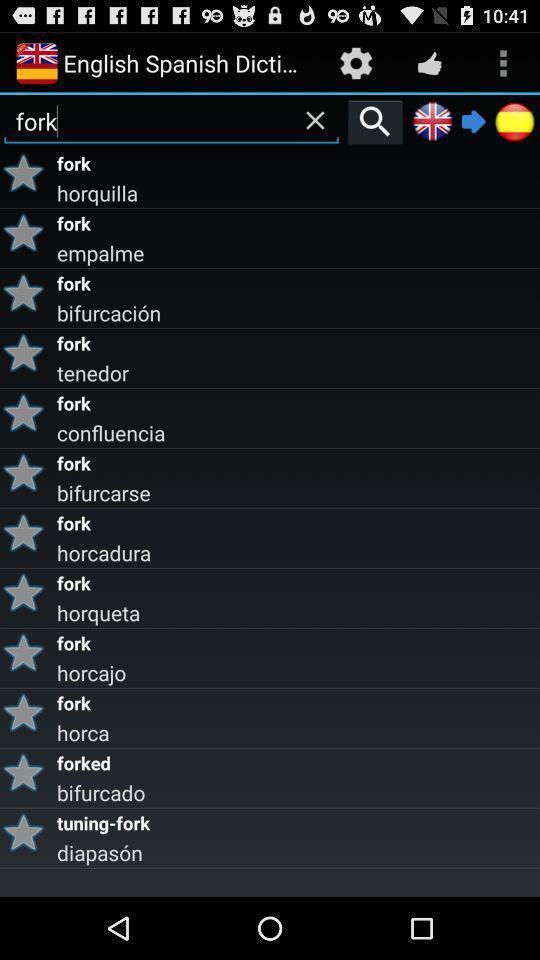Summarize the information in this screenshot. Search page for word finding in the dictionary app. 